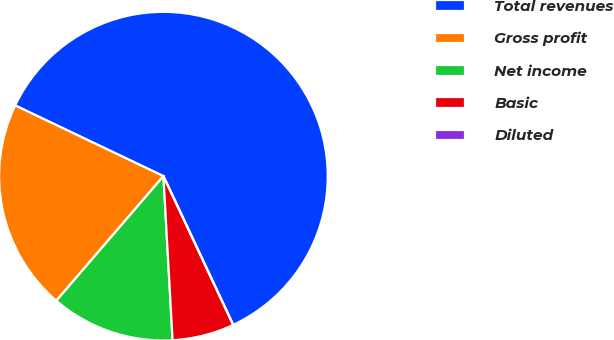Convert chart. <chart><loc_0><loc_0><loc_500><loc_500><pie_chart><fcel>Total revenues<fcel>Gross profit<fcel>Net income<fcel>Basic<fcel>Diluted<nl><fcel>60.94%<fcel>20.78%<fcel>12.19%<fcel>6.09%<fcel>0.0%<nl></chart> 